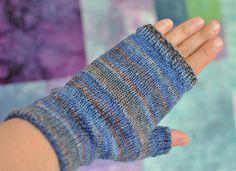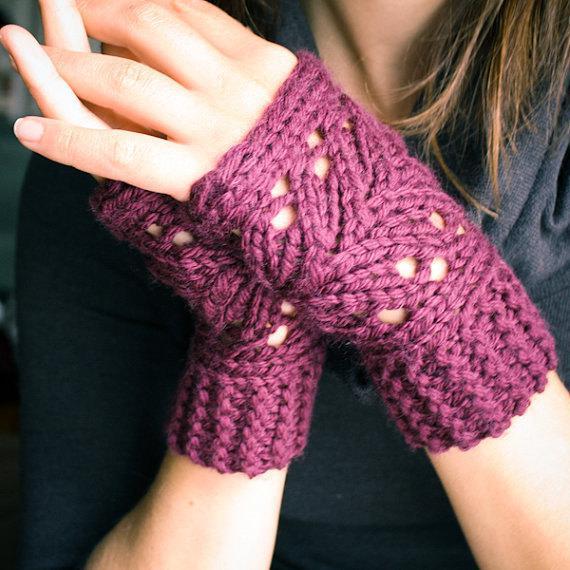The first image is the image on the left, the second image is the image on the right. For the images displayed, is the sentence "An image includes a hand wearing a solid-blue fingerless mitten." factually correct? Answer yes or no. No. The first image is the image on the left, the second image is the image on the right. Assess this claim about the two images: "In one of the images there is a single mitten worn on an empty hand.". Correct or not? Answer yes or no. Yes. 